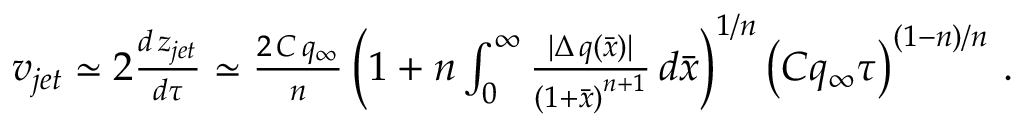Convert formula to latex. <formula><loc_0><loc_0><loc_500><loc_500>\begin{array} { r l } & { v _ { j e t } \simeq 2 \frac { d \, z _ { j e t } } { d \tau } \simeq \frac { 2 \, C \, q _ { \infty } } { n } \left ( 1 + n \int _ { 0 } ^ { \infty } \frac { | \Delta \, q ( \bar { x } ) | } { \left ( 1 + \bar { x } \right ) ^ { n + 1 } } \, d \bar { x } \right ) ^ { 1 / n } \left ( C q _ { \infty } \tau \right ) ^ { ( 1 - n ) / n } \, . } \end{array}</formula> 